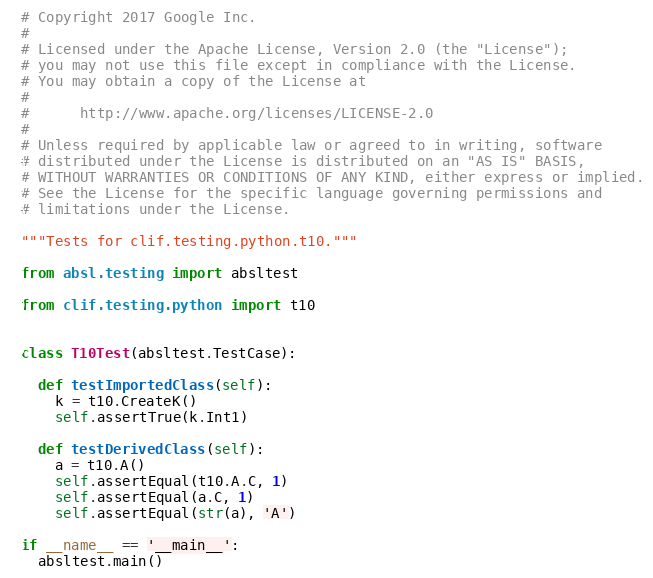<code> <loc_0><loc_0><loc_500><loc_500><_Python_># Copyright 2017 Google Inc.
#
# Licensed under the Apache License, Version 2.0 (the "License");
# you may not use this file except in compliance with the License.
# You may obtain a copy of the License at
#
#      http://www.apache.org/licenses/LICENSE-2.0
#
# Unless required by applicable law or agreed to in writing, software
# distributed under the License is distributed on an "AS IS" BASIS,
# WITHOUT WARRANTIES OR CONDITIONS OF ANY KIND, either express or implied.
# See the License for the specific language governing permissions and
# limitations under the License.

"""Tests for clif.testing.python.t10."""

from absl.testing import absltest

from clif.testing.python import t10


class T10Test(absltest.TestCase):

  def testImportedClass(self):
    k = t10.CreateK()
    self.assertTrue(k.Int1)

  def testDerivedClass(self):
    a = t10.A()
    self.assertEqual(t10.A.C, 1)
    self.assertEqual(a.C, 1)
    self.assertEqual(str(a), 'A')

if __name__ == '__main__':
  absltest.main()
</code> 